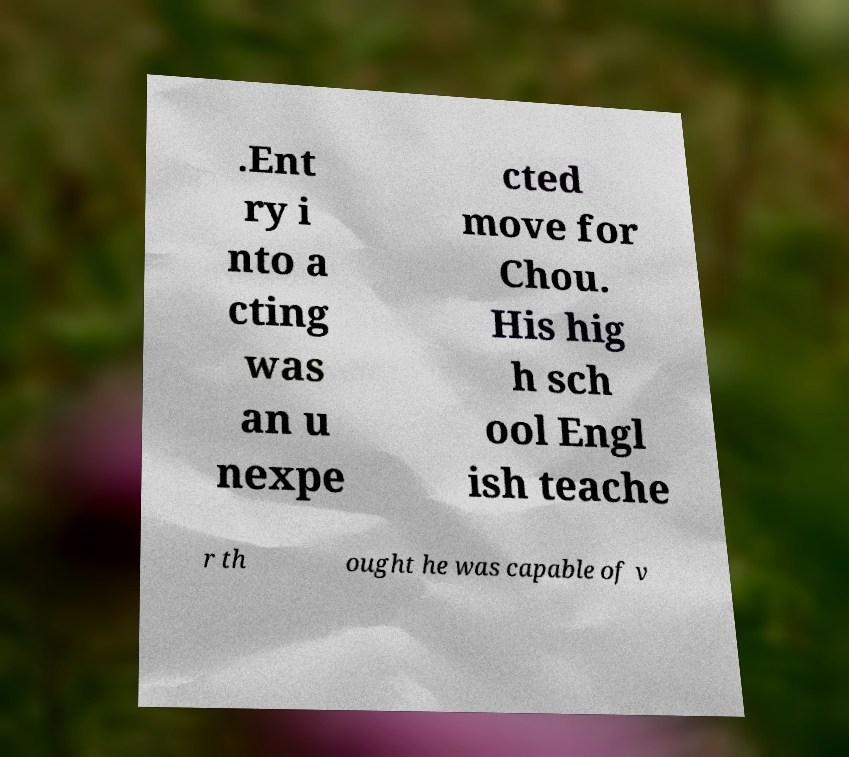What messages or text are displayed in this image? I need them in a readable, typed format. .Ent ry i nto a cting was an u nexpe cted move for Chou. His hig h sch ool Engl ish teache r th ought he was capable of v 